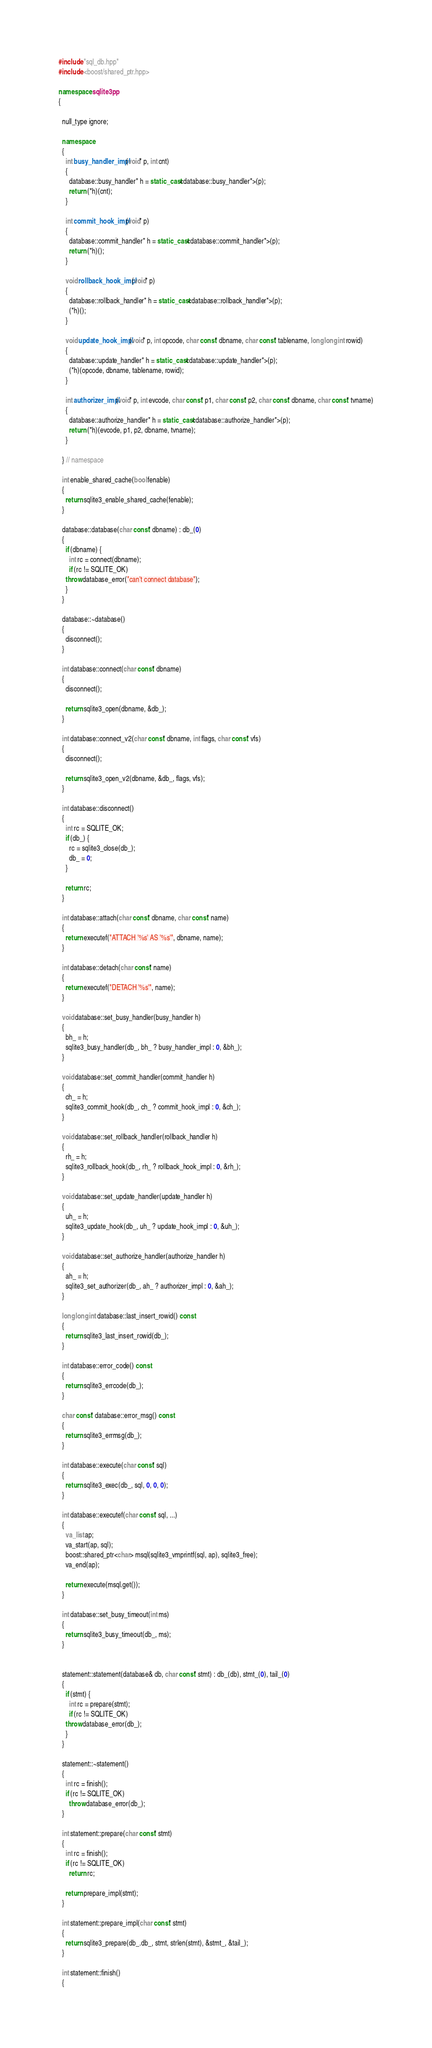<code> <loc_0><loc_0><loc_500><loc_500><_C++_>#include "sql_db.hpp"
#include <boost/shared_ptr.hpp>

namespace sqlite3pp
{

  null_type ignore;

  namespace
  {
    int busy_handler_impl(void* p, int cnt)
    {
      database::busy_handler* h = static_cast<database::busy_handler*>(p);
      return (*h)(cnt);
    }

    int commit_hook_impl(void* p)
    {
      database::commit_handler* h = static_cast<database::commit_handler*>(p);
      return (*h)();
    }

    void rollback_hook_impl(void* p)
    {
      database::rollback_handler* h = static_cast<database::rollback_handler*>(p);
      (*h)();
    }

    void update_hook_impl(void* p, int opcode, char const* dbname, char const* tablename, long long int rowid)
    {
      database::update_handler* h = static_cast<database::update_handler*>(p);
      (*h)(opcode, dbname, tablename, rowid);
    }

    int authorizer_impl(void* p, int evcode, char const* p1, char const* p2, char const* dbname, char const* tvname)
    {
      database::authorize_handler* h = static_cast<database::authorize_handler*>(p);
      return (*h)(evcode, p1, p2, dbname, tvname);
    }

  } // namespace

  int enable_shared_cache(bool fenable)
  {
    return sqlite3_enable_shared_cache(fenable);
  }

  database::database(char const* dbname) : db_(0)
  {
    if (dbname) {
      int rc = connect(dbname);
      if (rc != SQLITE_OK)
	throw database_error("can't connect database");
    }
  }

  database::~database()
  {
    disconnect();
  }

  int database::connect(char const* dbname)
  {
    disconnect();

    return sqlite3_open(dbname, &db_);
  }

  int database::connect_v2(char const* dbname, int flags, char const* vfs)
  {
    disconnect();

    return sqlite3_open_v2(dbname, &db_, flags, vfs);
  }

  int database::disconnect()
  {
    int rc = SQLITE_OK;
    if (db_) {
      rc = sqlite3_close(db_);
      db_ = 0;
    }

    return rc;
  }

  int database::attach(char const* dbname, char const* name)
  {
    return executef("ATTACH '%s' AS '%s'", dbname, name);
  }

  int database::detach(char const* name)
  {
    return executef("DETACH '%s'", name);
  }

  void database::set_busy_handler(busy_handler h)
  {
    bh_ = h;
    sqlite3_busy_handler(db_, bh_ ? busy_handler_impl : 0, &bh_);
  }

  void database::set_commit_handler(commit_handler h)
  {
    ch_ = h;
    sqlite3_commit_hook(db_, ch_ ? commit_hook_impl : 0, &ch_);
  }

  void database::set_rollback_handler(rollback_handler h)
  {
    rh_ = h;
    sqlite3_rollback_hook(db_, rh_ ? rollback_hook_impl : 0, &rh_);
  }

  void database::set_update_handler(update_handler h)
  {
    uh_ = h;
    sqlite3_update_hook(db_, uh_ ? update_hook_impl : 0, &uh_);
  }

  void database::set_authorize_handler(authorize_handler h)
  {
    ah_ = h;
    sqlite3_set_authorizer(db_, ah_ ? authorizer_impl : 0, &ah_);
  }

  long long int database::last_insert_rowid() const
  {
    return sqlite3_last_insert_rowid(db_);
  }

  int database::error_code() const
  {
    return sqlite3_errcode(db_);
  }

  char const* database::error_msg() const
  {
    return sqlite3_errmsg(db_);
  }

  int database::execute(char const* sql)
  {
    return sqlite3_exec(db_, sql, 0, 0, 0);
  }

  int database::executef(char const* sql, ...)
  {
    va_list ap;
    va_start(ap, sql);
    boost::shared_ptr<char> msql(sqlite3_vmprintf(sql, ap), sqlite3_free);
    va_end(ap);

    return execute(msql.get());
  }

  int database::set_busy_timeout(int ms)
  {
    return sqlite3_busy_timeout(db_, ms);
  }


  statement::statement(database& db, char const* stmt) : db_(db), stmt_(0), tail_(0)
  {
    if (stmt) {
      int rc = prepare(stmt);
      if (rc != SQLITE_OK)
	throw database_error(db_);
    }
  }

  statement::~statement()
  {
    int rc = finish();
    if (rc != SQLITE_OK)
      throw database_error(db_);
  }

  int statement::prepare(char const* stmt)
  {
    int rc = finish();
    if (rc != SQLITE_OK)
      return rc;

    return prepare_impl(stmt);
  }

  int statement::prepare_impl(char const* stmt)
  {
    return sqlite3_prepare(db_.db_, stmt, strlen(stmt), &stmt_, &tail_);
  }

  int statement::finish()
  {</code> 